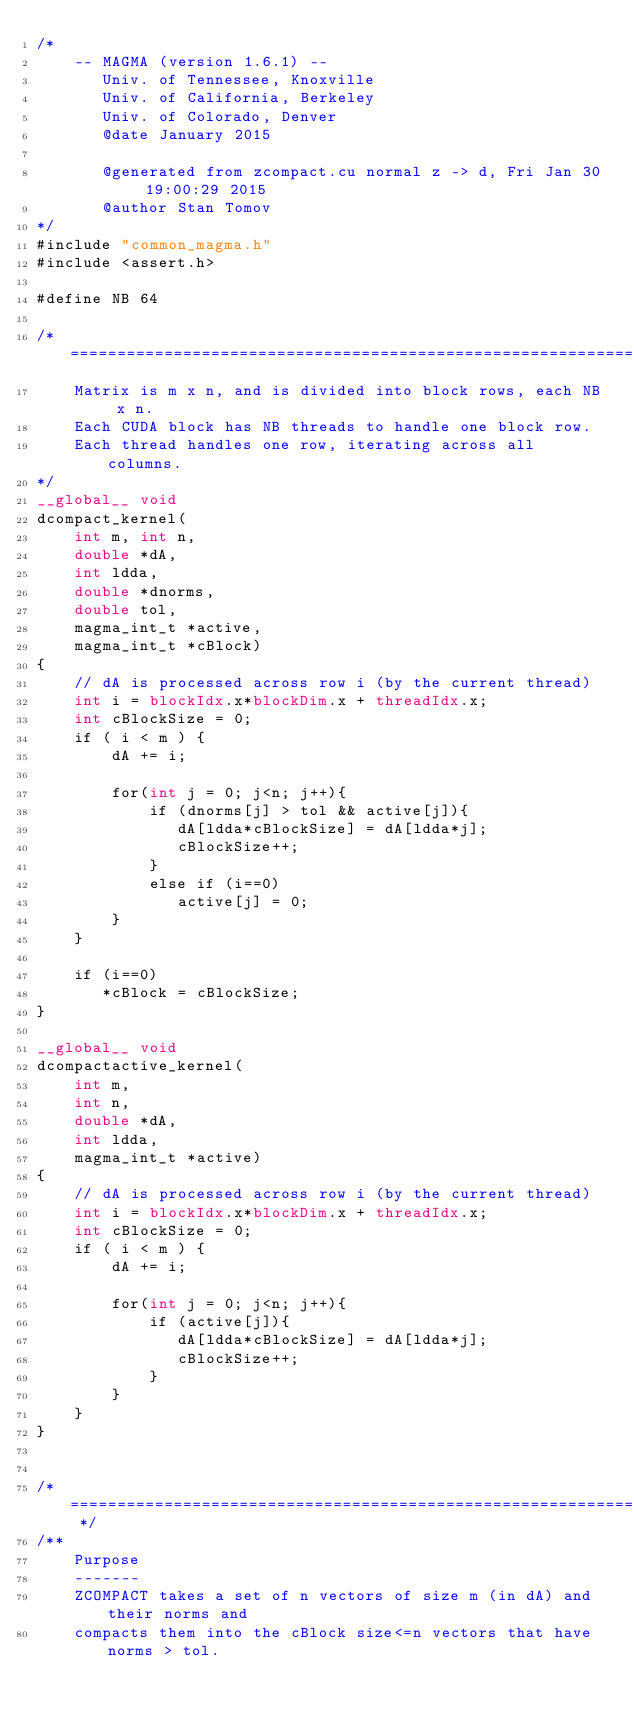<code> <loc_0><loc_0><loc_500><loc_500><_Cuda_>/*
    -- MAGMA (version 1.6.1) --
       Univ. of Tennessee, Knoxville
       Univ. of California, Berkeley
       Univ. of Colorado, Denver
       @date January 2015

       @generated from zcompact.cu normal z -> d, Fri Jan 30 19:00:29 2015
       @author Stan Tomov
*/
#include "common_magma.h"
#include <assert.h>

#define NB 64

/* =====================================================================
    Matrix is m x n, and is divided into block rows, each NB x n.
    Each CUDA block has NB threads to handle one block row.
    Each thread handles one row, iterating across all columns.
*/
__global__ void
dcompact_kernel(
    int m, int n,
    double *dA, 
    int ldda,
    double *dnorms, 
    double tol,
    magma_int_t *active, 
    magma_int_t *cBlock)
{
    // dA is processed across row i (by the current thread)
    int i = blockIdx.x*blockDim.x + threadIdx.x;
    int cBlockSize = 0;
    if ( i < m ) {
        dA += i;
        
        for(int j = 0; j<n; j++){
            if (dnorms[j] > tol && active[j]){
               dA[ldda*cBlockSize] = dA[ldda*j];
               cBlockSize++;
            }
            else if (i==0)
               active[j] = 0;
        }
    }

    if (i==0)
       *cBlock = cBlockSize;
}

__global__ void
dcompactactive_kernel(
    int m, 
    int n,
    double *dA, 
    int ldda,
    magma_int_t *active)
{
    // dA is processed across row i (by the current thread)
    int i = blockIdx.x*blockDim.x + threadIdx.x;
    int cBlockSize = 0;
    if ( i < m ) {
        dA += i;

        for(int j = 0; j<n; j++){
            if (active[j]){
               dA[ldda*cBlockSize] = dA[ldda*j];
               cBlockSize++;
            }
        }
    }
}


/* ===================================================================== */
/**
    Purpose
    -------
    ZCOMPACT takes a set of n vectors of size m (in dA) and their norms and
    compacts them into the cBlock size<=n vectors that have norms > tol.</code> 